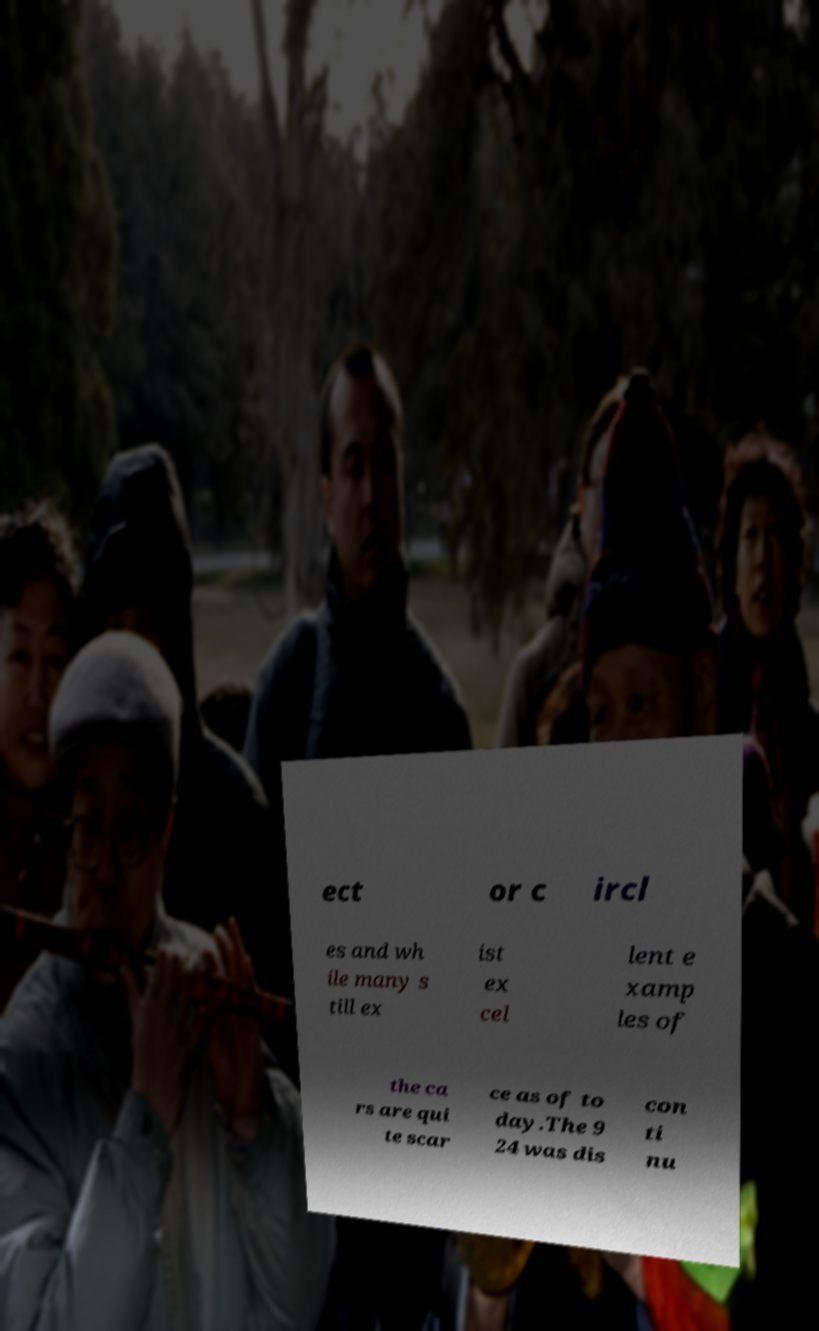Could you assist in decoding the text presented in this image and type it out clearly? ect or c ircl es and wh ile many s till ex ist ex cel lent e xamp les of the ca rs are qui te scar ce as of to day.The 9 24 was dis con ti nu 